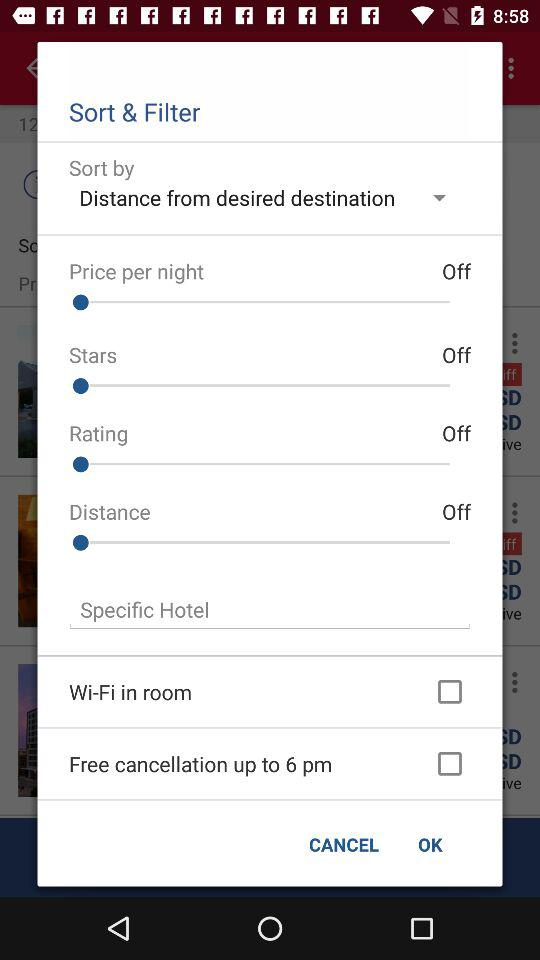Which option is selected for "Sort by"? The selected option is "Distance from desired destination". 